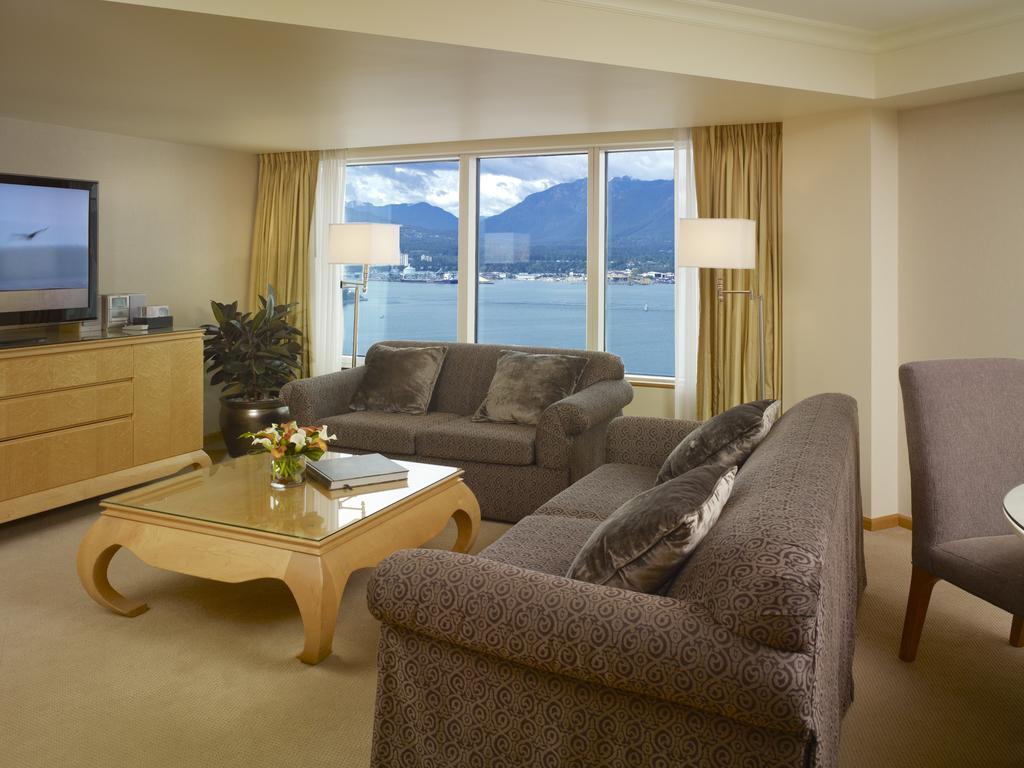Can you describe this image briefly? There is a flower vase and a book on a table near pillows arranged on the two sofas which are on the floor. In front of them, there is a monitor and other objects on the table. On the right side, there is a chair arranged on the floor. In the background, there is a glass window. Through this window, we can see, there is water, a mountain and clouds in the sky. 